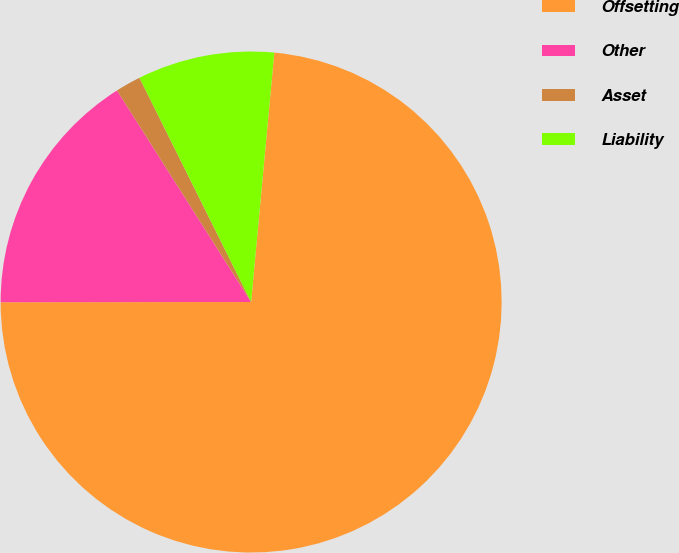Convert chart to OTSL. <chart><loc_0><loc_0><loc_500><loc_500><pie_chart><fcel>Offsetting<fcel>Other<fcel>Asset<fcel>Liability<nl><fcel>73.52%<fcel>16.02%<fcel>1.64%<fcel>8.83%<nl></chart> 